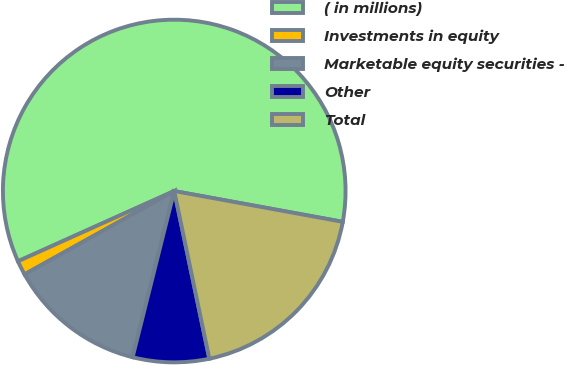<chart> <loc_0><loc_0><loc_500><loc_500><pie_chart><fcel>( in millions)<fcel>Investments in equity<fcel>Marketable equity securities -<fcel>Other<fcel>Total<nl><fcel>59.61%<fcel>1.36%<fcel>13.01%<fcel>7.19%<fcel>18.84%<nl></chart> 